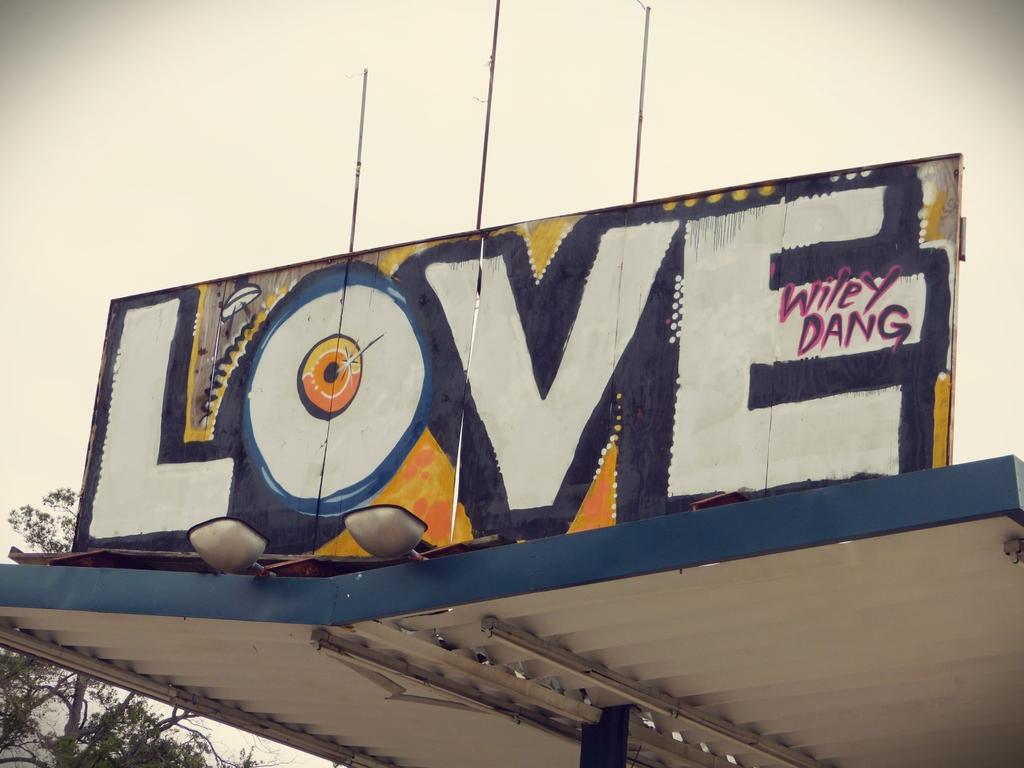Who made this love painting?
Your response must be concise. Wiley dang. What does the painting say?
Make the answer very short. Love. 